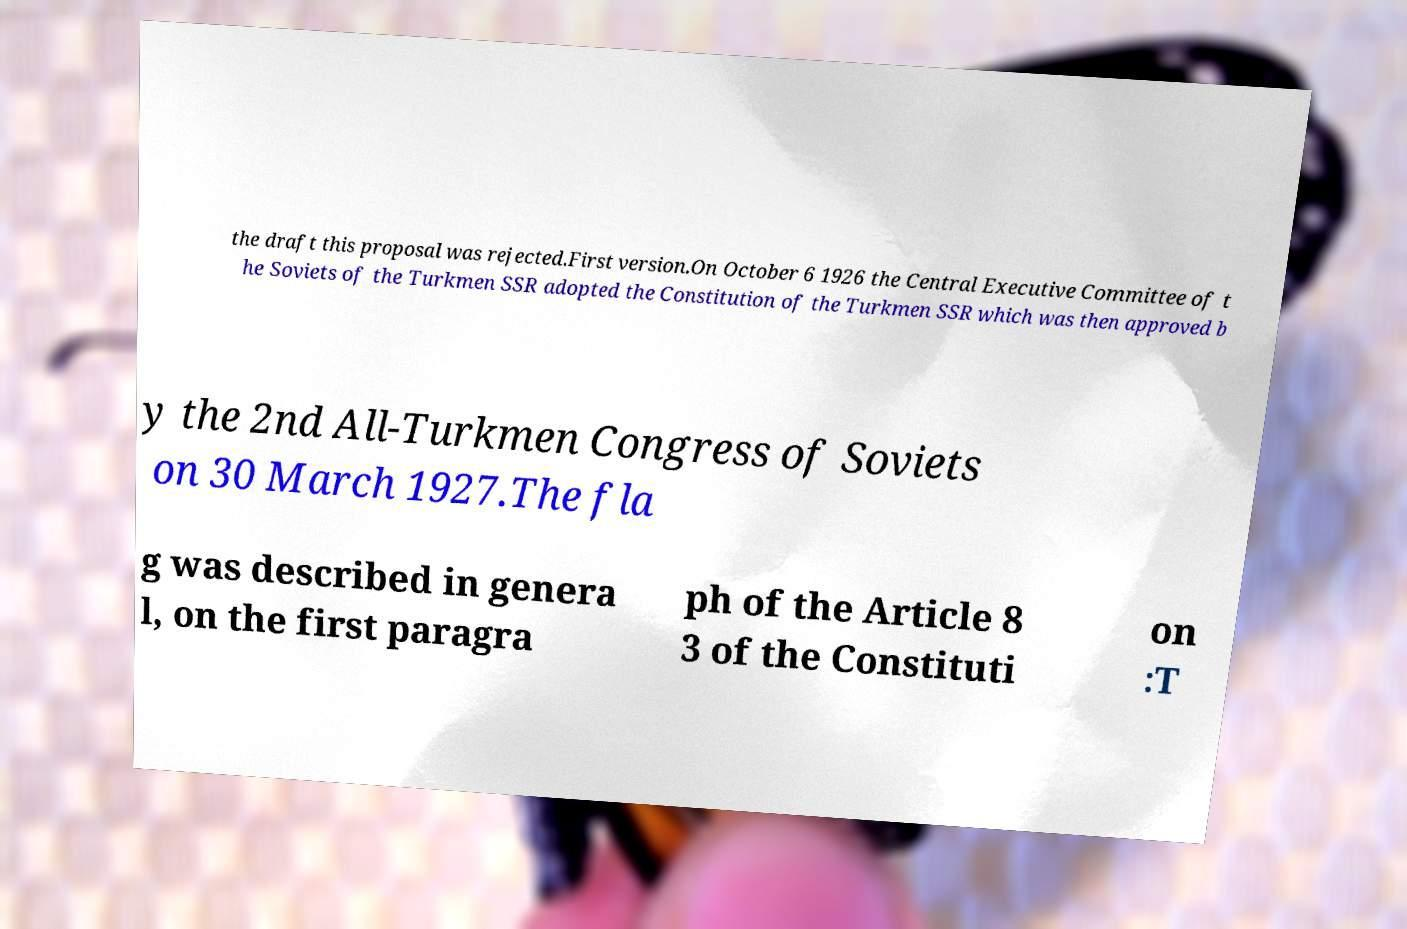Can you accurately transcribe the text from the provided image for me? the draft this proposal was rejected.First version.On October 6 1926 the Central Executive Committee of t he Soviets of the Turkmen SSR adopted the Constitution of the Turkmen SSR which was then approved b y the 2nd All-Turkmen Congress of Soviets on 30 March 1927.The fla g was described in genera l, on the first paragra ph of the Article 8 3 of the Constituti on :T 